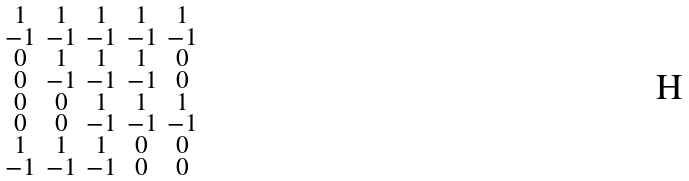<formula> <loc_0><loc_0><loc_500><loc_500>\begin{smallmatrix} 1 & 1 & 1 & 1 & 1 \\ - 1 & - 1 & - 1 & - 1 & - 1 \\ 0 & 1 & 1 & 1 & 0 \\ 0 & - 1 & - 1 & - 1 & 0 \\ 0 & 0 & 1 & 1 & 1 \\ 0 & 0 & - 1 & - 1 & - 1 \\ 1 & 1 & 1 & 0 & 0 \\ - 1 & - 1 & - 1 & 0 & 0 \end{smallmatrix}</formula> 